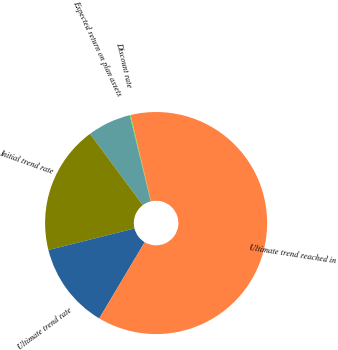Convert chart. <chart><loc_0><loc_0><loc_500><loc_500><pie_chart><fcel>Discount rate<fcel>Expected return on plan assets<fcel>Initial trend rate<fcel>Ultimate trend rate<fcel>Ultimate trend reached in<nl><fcel>0.12%<fcel>6.33%<fcel>18.76%<fcel>12.54%<fcel>62.25%<nl></chart> 